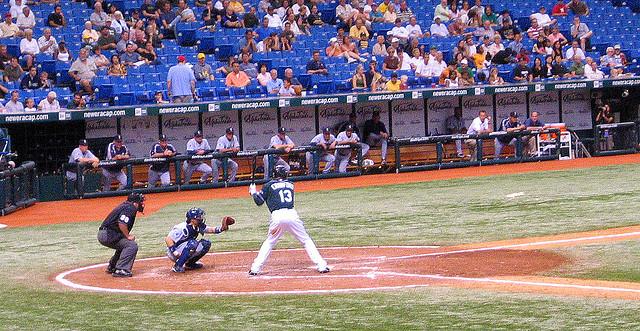What color are the grass?
Answer briefly. Green. What number is the batter?
Short answer required. 13. Is the batter swinging left handed or right handed?
Concise answer only. Left. 